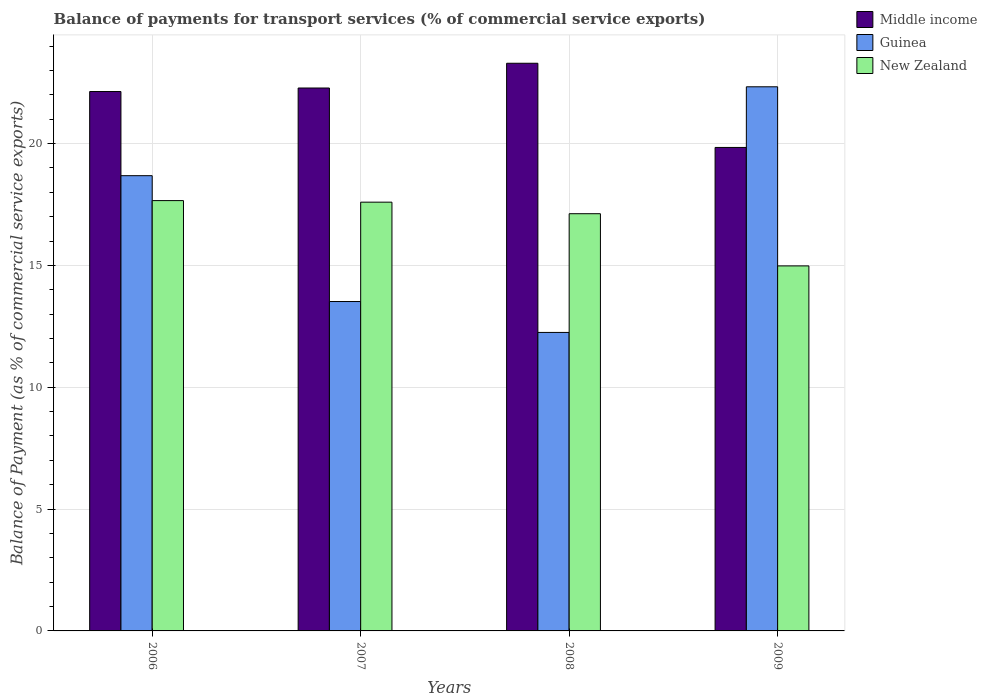How many different coloured bars are there?
Provide a succinct answer. 3. How many groups of bars are there?
Your answer should be very brief. 4. Are the number of bars per tick equal to the number of legend labels?
Give a very brief answer. Yes. How many bars are there on the 4th tick from the left?
Provide a short and direct response. 3. What is the balance of payments for transport services in Middle income in 2006?
Offer a terse response. 22.14. Across all years, what is the maximum balance of payments for transport services in New Zealand?
Your answer should be compact. 17.66. Across all years, what is the minimum balance of payments for transport services in Middle income?
Your response must be concise. 19.84. In which year was the balance of payments for transport services in Middle income maximum?
Make the answer very short. 2008. In which year was the balance of payments for transport services in Middle income minimum?
Your response must be concise. 2009. What is the total balance of payments for transport services in Middle income in the graph?
Give a very brief answer. 87.55. What is the difference between the balance of payments for transport services in Guinea in 2008 and that in 2009?
Your answer should be compact. -10.08. What is the difference between the balance of payments for transport services in Middle income in 2007 and the balance of payments for transport services in Guinea in 2009?
Offer a terse response. -0.05. What is the average balance of payments for transport services in New Zealand per year?
Keep it short and to the point. 16.84. In the year 2007, what is the difference between the balance of payments for transport services in Guinea and balance of payments for transport services in Middle income?
Your answer should be very brief. -8.76. What is the ratio of the balance of payments for transport services in New Zealand in 2007 to that in 2008?
Give a very brief answer. 1.03. Is the balance of payments for transport services in Middle income in 2008 less than that in 2009?
Give a very brief answer. No. What is the difference between the highest and the second highest balance of payments for transport services in Guinea?
Provide a succinct answer. 3.65. What is the difference between the highest and the lowest balance of payments for transport services in Middle income?
Provide a succinct answer. 3.45. Is the sum of the balance of payments for transport services in Middle income in 2008 and 2009 greater than the maximum balance of payments for transport services in New Zealand across all years?
Ensure brevity in your answer.  Yes. What does the 2nd bar from the left in 2008 represents?
Offer a very short reply. Guinea. Are all the bars in the graph horizontal?
Your response must be concise. No. How many years are there in the graph?
Offer a very short reply. 4. Are the values on the major ticks of Y-axis written in scientific E-notation?
Your response must be concise. No. Where does the legend appear in the graph?
Your answer should be very brief. Top right. What is the title of the graph?
Ensure brevity in your answer.  Balance of payments for transport services (% of commercial service exports). What is the label or title of the X-axis?
Provide a succinct answer. Years. What is the label or title of the Y-axis?
Ensure brevity in your answer.  Balance of Payment (as % of commercial service exports). What is the Balance of Payment (as % of commercial service exports) in Middle income in 2006?
Your answer should be compact. 22.14. What is the Balance of Payment (as % of commercial service exports) in Guinea in 2006?
Your answer should be very brief. 18.68. What is the Balance of Payment (as % of commercial service exports) of New Zealand in 2006?
Your answer should be compact. 17.66. What is the Balance of Payment (as % of commercial service exports) of Middle income in 2007?
Offer a very short reply. 22.28. What is the Balance of Payment (as % of commercial service exports) in Guinea in 2007?
Make the answer very short. 13.52. What is the Balance of Payment (as % of commercial service exports) in New Zealand in 2007?
Your answer should be compact. 17.6. What is the Balance of Payment (as % of commercial service exports) of Middle income in 2008?
Your answer should be very brief. 23.3. What is the Balance of Payment (as % of commercial service exports) in Guinea in 2008?
Provide a short and direct response. 12.25. What is the Balance of Payment (as % of commercial service exports) of New Zealand in 2008?
Keep it short and to the point. 17.12. What is the Balance of Payment (as % of commercial service exports) in Middle income in 2009?
Your answer should be compact. 19.84. What is the Balance of Payment (as % of commercial service exports) of Guinea in 2009?
Provide a short and direct response. 22.33. What is the Balance of Payment (as % of commercial service exports) of New Zealand in 2009?
Keep it short and to the point. 14.98. Across all years, what is the maximum Balance of Payment (as % of commercial service exports) of Middle income?
Provide a short and direct response. 23.3. Across all years, what is the maximum Balance of Payment (as % of commercial service exports) in Guinea?
Ensure brevity in your answer.  22.33. Across all years, what is the maximum Balance of Payment (as % of commercial service exports) in New Zealand?
Offer a terse response. 17.66. Across all years, what is the minimum Balance of Payment (as % of commercial service exports) in Middle income?
Your response must be concise. 19.84. Across all years, what is the minimum Balance of Payment (as % of commercial service exports) in Guinea?
Keep it short and to the point. 12.25. Across all years, what is the minimum Balance of Payment (as % of commercial service exports) in New Zealand?
Provide a short and direct response. 14.98. What is the total Balance of Payment (as % of commercial service exports) of Middle income in the graph?
Provide a short and direct response. 87.55. What is the total Balance of Payment (as % of commercial service exports) in Guinea in the graph?
Make the answer very short. 66.78. What is the total Balance of Payment (as % of commercial service exports) in New Zealand in the graph?
Ensure brevity in your answer.  67.36. What is the difference between the Balance of Payment (as % of commercial service exports) in Middle income in 2006 and that in 2007?
Offer a terse response. -0.14. What is the difference between the Balance of Payment (as % of commercial service exports) in Guinea in 2006 and that in 2007?
Keep it short and to the point. 5.16. What is the difference between the Balance of Payment (as % of commercial service exports) of New Zealand in 2006 and that in 2007?
Keep it short and to the point. 0.06. What is the difference between the Balance of Payment (as % of commercial service exports) of Middle income in 2006 and that in 2008?
Your response must be concise. -1.16. What is the difference between the Balance of Payment (as % of commercial service exports) of Guinea in 2006 and that in 2008?
Your answer should be compact. 6.43. What is the difference between the Balance of Payment (as % of commercial service exports) of New Zealand in 2006 and that in 2008?
Make the answer very short. 0.54. What is the difference between the Balance of Payment (as % of commercial service exports) in Middle income in 2006 and that in 2009?
Keep it short and to the point. 2.29. What is the difference between the Balance of Payment (as % of commercial service exports) of Guinea in 2006 and that in 2009?
Offer a terse response. -3.65. What is the difference between the Balance of Payment (as % of commercial service exports) in New Zealand in 2006 and that in 2009?
Give a very brief answer. 2.68. What is the difference between the Balance of Payment (as % of commercial service exports) in Middle income in 2007 and that in 2008?
Your answer should be very brief. -1.02. What is the difference between the Balance of Payment (as % of commercial service exports) of Guinea in 2007 and that in 2008?
Keep it short and to the point. 1.27. What is the difference between the Balance of Payment (as % of commercial service exports) in New Zealand in 2007 and that in 2008?
Provide a short and direct response. 0.47. What is the difference between the Balance of Payment (as % of commercial service exports) in Middle income in 2007 and that in 2009?
Keep it short and to the point. 2.44. What is the difference between the Balance of Payment (as % of commercial service exports) in Guinea in 2007 and that in 2009?
Provide a succinct answer. -8.81. What is the difference between the Balance of Payment (as % of commercial service exports) of New Zealand in 2007 and that in 2009?
Offer a very short reply. 2.62. What is the difference between the Balance of Payment (as % of commercial service exports) of Middle income in 2008 and that in 2009?
Your answer should be very brief. 3.45. What is the difference between the Balance of Payment (as % of commercial service exports) of Guinea in 2008 and that in 2009?
Your response must be concise. -10.08. What is the difference between the Balance of Payment (as % of commercial service exports) of New Zealand in 2008 and that in 2009?
Make the answer very short. 2.14. What is the difference between the Balance of Payment (as % of commercial service exports) in Middle income in 2006 and the Balance of Payment (as % of commercial service exports) in Guinea in 2007?
Give a very brief answer. 8.62. What is the difference between the Balance of Payment (as % of commercial service exports) of Middle income in 2006 and the Balance of Payment (as % of commercial service exports) of New Zealand in 2007?
Ensure brevity in your answer.  4.54. What is the difference between the Balance of Payment (as % of commercial service exports) in Guinea in 2006 and the Balance of Payment (as % of commercial service exports) in New Zealand in 2007?
Give a very brief answer. 1.09. What is the difference between the Balance of Payment (as % of commercial service exports) in Middle income in 2006 and the Balance of Payment (as % of commercial service exports) in Guinea in 2008?
Offer a terse response. 9.89. What is the difference between the Balance of Payment (as % of commercial service exports) of Middle income in 2006 and the Balance of Payment (as % of commercial service exports) of New Zealand in 2008?
Your response must be concise. 5.01. What is the difference between the Balance of Payment (as % of commercial service exports) of Guinea in 2006 and the Balance of Payment (as % of commercial service exports) of New Zealand in 2008?
Provide a short and direct response. 1.56. What is the difference between the Balance of Payment (as % of commercial service exports) in Middle income in 2006 and the Balance of Payment (as % of commercial service exports) in Guinea in 2009?
Make the answer very short. -0.19. What is the difference between the Balance of Payment (as % of commercial service exports) in Middle income in 2006 and the Balance of Payment (as % of commercial service exports) in New Zealand in 2009?
Provide a succinct answer. 7.16. What is the difference between the Balance of Payment (as % of commercial service exports) of Guinea in 2006 and the Balance of Payment (as % of commercial service exports) of New Zealand in 2009?
Provide a succinct answer. 3.7. What is the difference between the Balance of Payment (as % of commercial service exports) in Middle income in 2007 and the Balance of Payment (as % of commercial service exports) in Guinea in 2008?
Give a very brief answer. 10.03. What is the difference between the Balance of Payment (as % of commercial service exports) of Middle income in 2007 and the Balance of Payment (as % of commercial service exports) of New Zealand in 2008?
Offer a very short reply. 5.16. What is the difference between the Balance of Payment (as % of commercial service exports) of Guinea in 2007 and the Balance of Payment (as % of commercial service exports) of New Zealand in 2008?
Offer a terse response. -3.6. What is the difference between the Balance of Payment (as % of commercial service exports) of Middle income in 2007 and the Balance of Payment (as % of commercial service exports) of Guinea in 2009?
Your answer should be very brief. -0.05. What is the difference between the Balance of Payment (as % of commercial service exports) in Middle income in 2007 and the Balance of Payment (as % of commercial service exports) in New Zealand in 2009?
Ensure brevity in your answer.  7.3. What is the difference between the Balance of Payment (as % of commercial service exports) in Guinea in 2007 and the Balance of Payment (as % of commercial service exports) in New Zealand in 2009?
Your answer should be very brief. -1.46. What is the difference between the Balance of Payment (as % of commercial service exports) in Middle income in 2008 and the Balance of Payment (as % of commercial service exports) in Guinea in 2009?
Offer a very short reply. 0.97. What is the difference between the Balance of Payment (as % of commercial service exports) in Middle income in 2008 and the Balance of Payment (as % of commercial service exports) in New Zealand in 2009?
Keep it short and to the point. 8.32. What is the difference between the Balance of Payment (as % of commercial service exports) in Guinea in 2008 and the Balance of Payment (as % of commercial service exports) in New Zealand in 2009?
Your answer should be very brief. -2.73. What is the average Balance of Payment (as % of commercial service exports) of Middle income per year?
Your answer should be very brief. 21.89. What is the average Balance of Payment (as % of commercial service exports) in Guinea per year?
Make the answer very short. 16.69. What is the average Balance of Payment (as % of commercial service exports) of New Zealand per year?
Provide a succinct answer. 16.84. In the year 2006, what is the difference between the Balance of Payment (as % of commercial service exports) of Middle income and Balance of Payment (as % of commercial service exports) of Guinea?
Keep it short and to the point. 3.45. In the year 2006, what is the difference between the Balance of Payment (as % of commercial service exports) in Middle income and Balance of Payment (as % of commercial service exports) in New Zealand?
Offer a terse response. 4.48. In the year 2006, what is the difference between the Balance of Payment (as % of commercial service exports) of Guinea and Balance of Payment (as % of commercial service exports) of New Zealand?
Give a very brief answer. 1.02. In the year 2007, what is the difference between the Balance of Payment (as % of commercial service exports) in Middle income and Balance of Payment (as % of commercial service exports) in Guinea?
Offer a terse response. 8.76. In the year 2007, what is the difference between the Balance of Payment (as % of commercial service exports) in Middle income and Balance of Payment (as % of commercial service exports) in New Zealand?
Your answer should be very brief. 4.68. In the year 2007, what is the difference between the Balance of Payment (as % of commercial service exports) of Guinea and Balance of Payment (as % of commercial service exports) of New Zealand?
Provide a succinct answer. -4.08. In the year 2008, what is the difference between the Balance of Payment (as % of commercial service exports) of Middle income and Balance of Payment (as % of commercial service exports) of Guinea?
Provide a succinct answer. 11.05. In the year 2008, what is the difference between the Balance of Payment (as % of commercial service exports) in Middle income and Balance of Payment (as % of commercial service exports) in New Zealand?
Provide a succinct answer. 6.17. In the year 2008, what is the difference between the Balance of Payment (as % of commercial service exports) in Guinea and Balance of Payment (as % of commercial service exports) in New Zealand?
Make the answer very short. -4.87. In the year 2009, what is the difference between the Balance of Payment (as % of commercial service exports) of Middle income and Balance of Payment (as % of commercial service exports) of Guinea?
Provide a succinct answer. -2.49. In the year 2009, what is the difference between the Balance of Payment (as % of commercial service exports) in Middle income and Balance of Payment (as % of commercial service exports) in New Zealand?
Ensure brevity in your answer.  4.86. In the year 2009, what is the difference between the Balance of Payment (as % of commercial service exports) in Guinea and Balance of Payment (as % of commercial service exports) in New Zealand?
Provide a short and direct response. 7.35. What is the ratio of the Balance of Payment (as % of commercial service exports) of Middle income in 2006 to that in 2007?
Your answer should be very brief. 0.99. What is the ratio of the Balance of Payment (as % of commercial service exports) of Guinea in 2006 to that in 2007?
Keep it short and to the point. 1.38. What is the ratio of the Balance of Payment (as % of commercial service exports) of Middle income in 2006 to that in 2008?
Your answer should be very brief. 0.95. What is the ratio of the Balance of Payment (as % of commercial service exports) of Guinea in 2006 to that in 2008?
Keep it short and to the point. 1.53. What is the ratio of the Balance of Payment (as % of commercial service exports) of New Zealand in 2006 to that in 2008?
Your response must be concise. 1.03. What is the ratio of the Balance of Payment (as % of commercial service exports) of Middle income in 2006 to that in 2009?
Provide a succinct answer. 1.12. What is the ratio of the Balance of Payment (as % of commercial service exports) of Guinea in 2006 to that in 2009?
Your response must be concise. 0.84. What is the ratio of the Balance of Payment (as % of commercial service exports) of New Zealand in 2006 to that in 2009?
Provide a short and direct response. 1.18. What is the ratio of the Balance of Payment (as % of commercial service exports) of Middle income in 2007 to that in 2008?
Offer a terse response. 0.96. What is the ratio of the Balance of Payment (as % of commercial service exports) of Guinea in 2007 to that in 2008?
Your answer should be compact. 1.1. What is the ratio of the Balance of Payment (as % of commercial service exports) in New Zealand in 2007 to that in 2008?
Your answer should be compact. 1.03. What is the ratio of the Balance of Payment (as % of commercial service exports) in Middle income in 2007 to that in 2009?
Your answer should be very brief. 1.12. What is the ratio of the Balance of Payment (as % of commercial service exports) in Guinea in 2007 to that in 2009?
Ensure brevity in your answer.  0.61. What is the ratio of the Balance of Payment (as % of commercial service exports) in New Zealand in 2007 to that in 2009?
Your response must be concise. 1.17. What is the ratio of the Balance of Payment (as % of commercial service exports) of Middle income in 2008 to that in 2009?
Give a very brief answer. 1.17. What is the ratio of the Balance of Payment (as % of commercial service exports) of Guinea in 2008 to that in 2009?
Your answer should be very brief. 0.55. What is the ratio of the Balance of Payment (as % of commercial service exports) of New Zealand in 2008 to that in 2009?
Offer a very short reply. 1.14. What is the difference between the highest and the second highest Balance of Payment (as % of commercial service exports) in Middle income?
Your response must be concise. 1.02. What is the difference between the highest and the second highest Balance of Payment (as % of commercial service exports) of Guinea?
Your answer should be compact. 3.65. What is the difference between the highest and the second highest Balance of Payment (as % of commercial service exports) of New Zealand?
Keep it short and to the point. 0.06. What is the difference between the highest and the lowest Balance of Payment (as % of commercial service exports) in Middle income?
Give a very brief answer. 3.45. What is the difference between the highest and the lowest Balance of Payment (as % of commercial service exports) in Guinea?
Provide a short and direct response. 10.08. What is the difference between the highest and the lowest Balance of Payment (as % of commercial service exports) in New Zealand?
Offer a terse response. 2.68. 